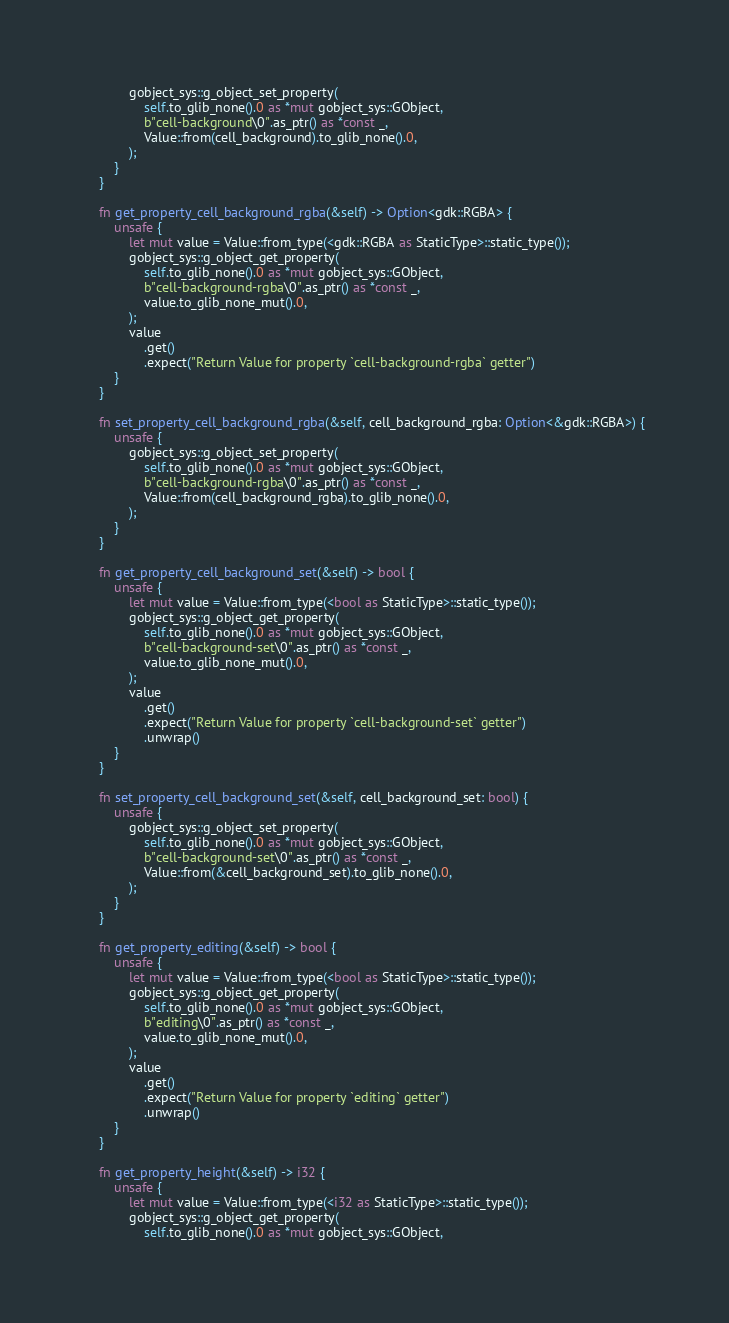<code> <loc_0><loc_0><loc_500><loc_500><_Rust_>            gobject_sys::g_object_set_property(
                self.to_glib_none().0 as *mut gobject_sys::GObject,
                b"cell-background\0".as_ptr() as *const _,
                Value::from(cell_background).to_glib_none().0,
            );
        }
    }

    fn get_property_cell_background_rgba(&self) -> Option<gdk::RGBA> {
        unsafe {
            let mut value = Value::from_type(<gdk::RGBA as StaticType>::static_type());
            gobject_sys::g_object_get_property(
                self.to_glib_none().0 as *mut gobject_sys::GObject,
                b"cell-background-rgba\0".as_ptr() as *const _,
                value.to_glib_none_mut().0,
            );
            value
                .get()
                .expect("Return Value for property `cell-background-rgba` getter")
        }
    }

    fn set_property_cell_background_rgba(&self, cell_background_rgba: Option<&gdk::RGBA>) {
        unsafe {
            gobject_sys::g_object_set_property(
                self.to_glib_none().0 as *mut gobject_sys::GObject,
                b"cell-background-rgba\0".as_ptr() as *const _,
                Value::from(cell_background_rgba).to_glib_none().0,
            );
        }
    }

    fn get_property_cell_background_set(&self) -> bool {
        unsafe {
            let mut value = Value::from_type(<bool as StaticType>::static_type());
            gobject_sys::g_object_get_property(
                self.to_glib_none().0 as *mut gobject_sys::GObject,
                b"cell-background-set\0".as_ptr() as *const _,
                value.to_glib_none_mut().0,
            );
            value
                .get()
                .expect("Return Value for property `cell-background-set` getter")
                .unwrap()
        }
    }

    fn set_property_cell_background_set(&self, cell_background_set: bool) {
        unsafe {
            gobject_sys::g_object_set_property(
                self.to_glib_none().0 as *mut gobject_sys::GObject,
                b"cell-background-set\0".as_ptr() as *const _,
                Value::from(&cell_background_set).to_glib_none().0,
            );
        }
    }

    fn get_property_editing(&self) -> bool {
        unsafe {
            let mut value = Value::from_type(<bool as StaticType>::static_type());
            gobject_sys::g_object_get_property(
                self.to_glib_none().0 as *mut gobject_sys::GObject,
                b"editing\0".as_ptr() as *const _,
                value.to_glib_none_mut().0,
            );
            value
                .get()
                .expect("Return Value for property `editing` getter")
                .unwrap()
        }
    }

    fn get_property_height(&self) -> i32 {
        unsafe {
            let mut value = Value::from_type(<i32 as StaticType>::static_type());
            gobject_sys::g_object_get_property(
                self.to_glib_none().0 as *mut gobject_sys::GObject,</code> 